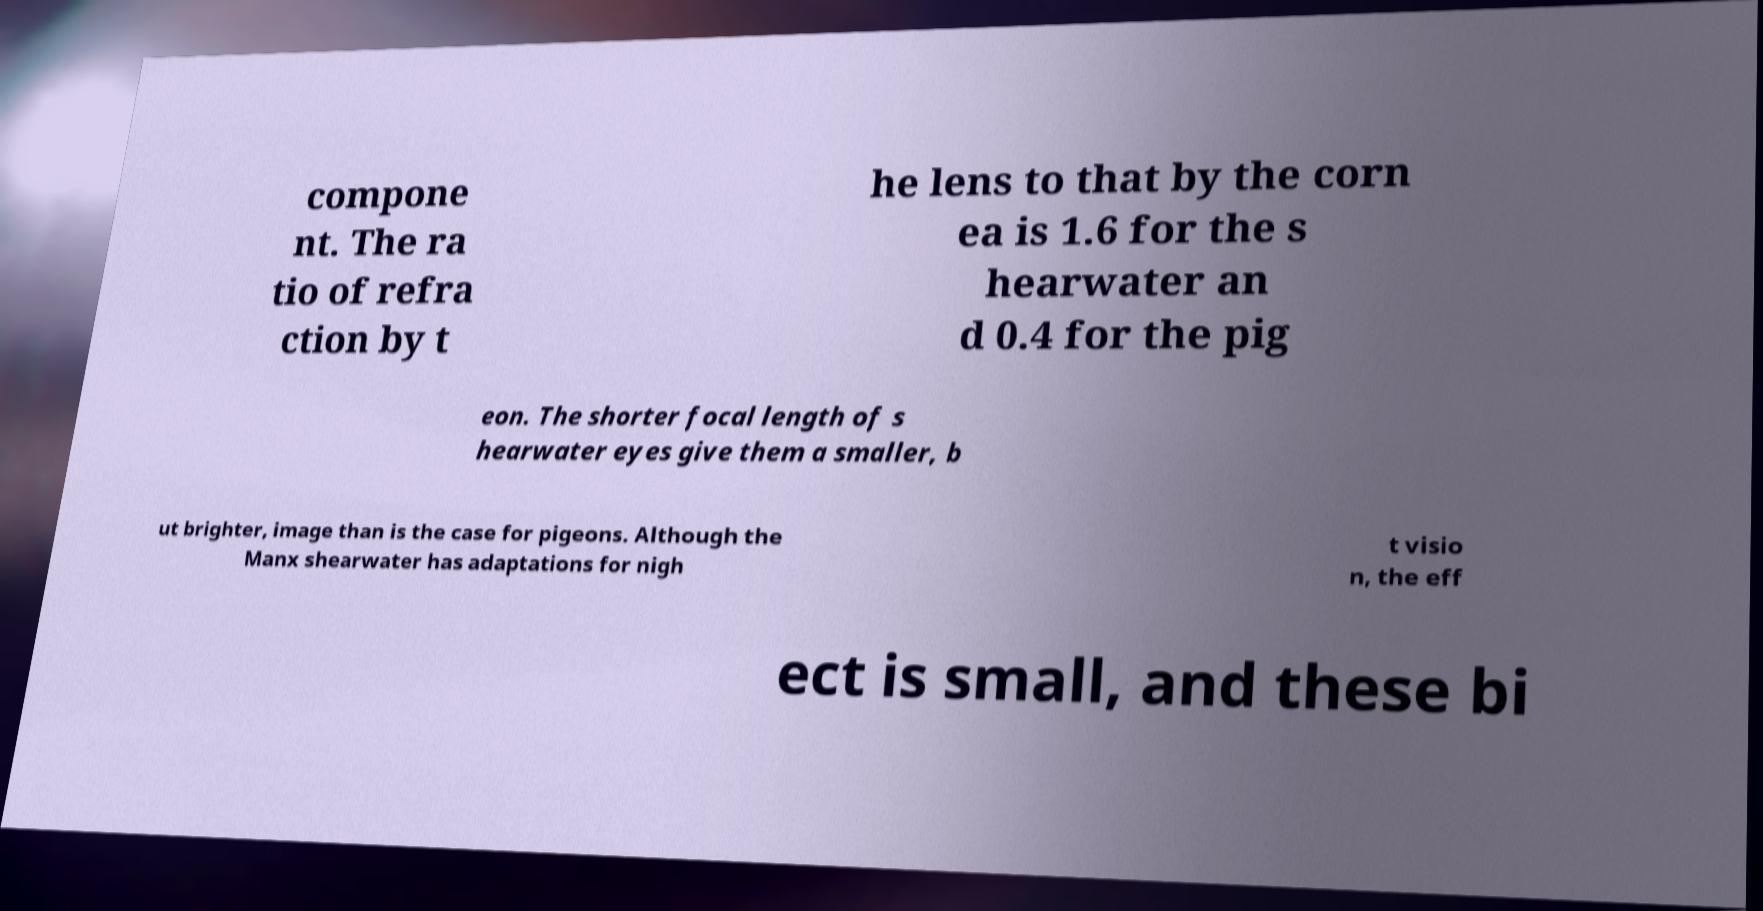Can you accurately transcribe the text from the provided image for me? compone nt. The ra tio of refra ction by t he lens to that by the corn ea is 1.6 for the s hearwater an d 0.4 for the pig eon. The shorter focal length of s hearwater eyes give them a smaller, b ut brighter, image than is the case for pigeons. Although the Manx shearwater has adaptations for nigh t visio n, the eff ect is small, and these bi 